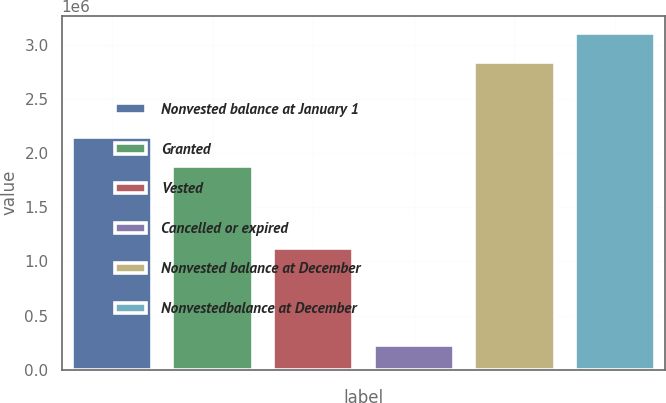Convert chart to OTSL. <chart><loc_0><loc_0><loc_500><loc_500><bar_chart><fcel>Nonvested balance at January 1<fcel>Granted<fcel>Vested<fcel>Cancelled or expired<fcel>Nonvested balance at December<fcel>Nonvestedbalance at December<nl><fcel>2.1522e+06<fcel>1.88426e+06<fcel>1.12118e+06<fcel>232372<fcel>2.84444e+06<fcel>3.11238e+06<nl></chart> 